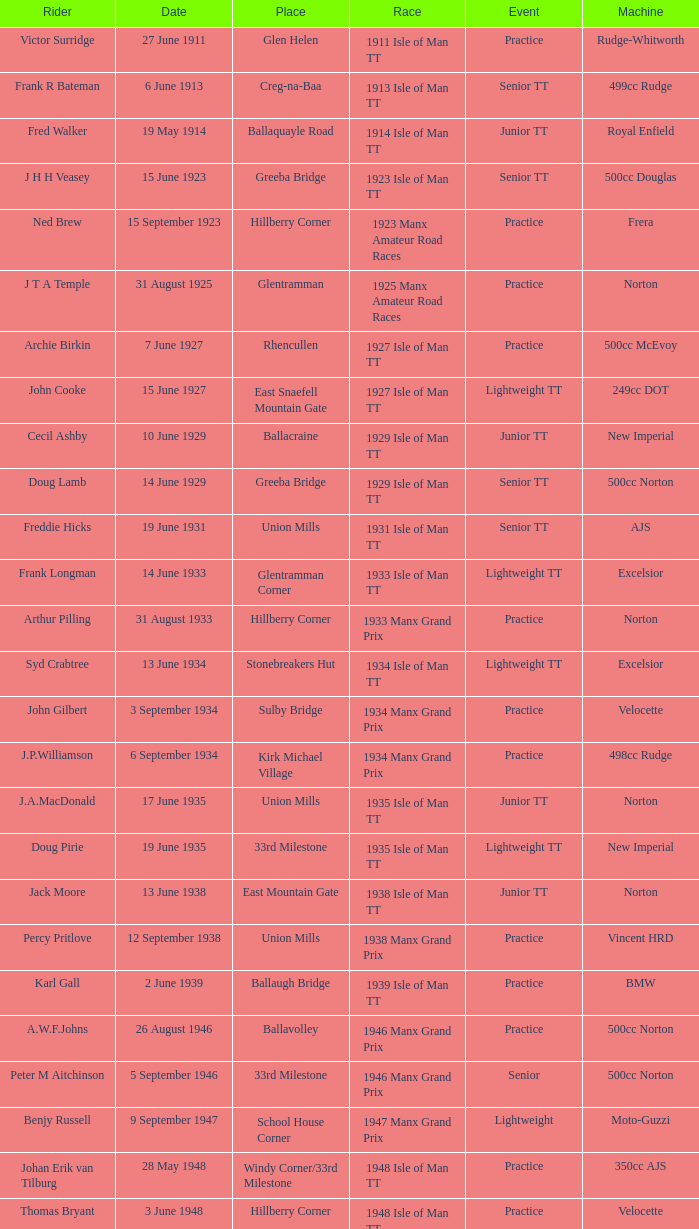What was the location of the 249cc yamaha motorcycle? Glentramman. 